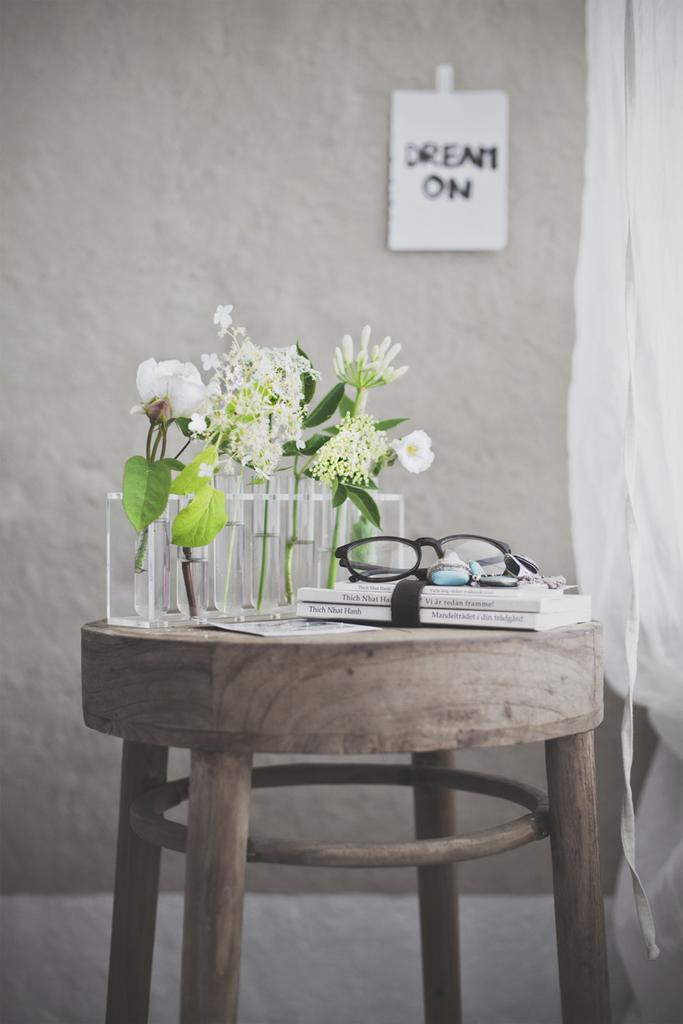What object is present on the stool in the image? There is a glass, a flower vase, a book, and a pair of spectacles on the stool in the image. What is the purpose of the glass on the stool? The purpose of the glass on the stool is likely for holding a beverage. What is the purpose of the flower vase on the stool? The purpose of the flower vase on the stool is likely to hold flowers. What is the purpose of the book on the stool? The purpose of the book on the stool is likely for reading. What is the purpose of the pair of spectacles on the stool? The purpose of the pair of spectacles on the stool is likely for correcting vision while reading or performing other tasks. What can be seen in the background of the image? In the background of the image, there is a beautiful wall, a poster, and a curtain. What type of prose can be heard being read from the book in the image? There is no audio in the image, so it is not possible to determine what type of prose might be read from the book. 